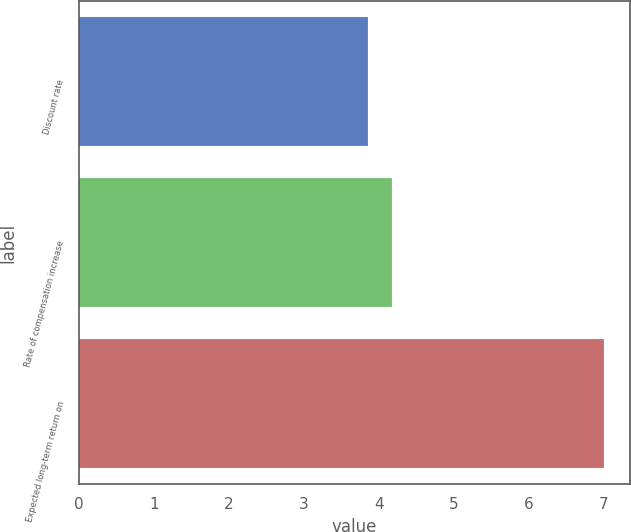<chart> <loc_0><loc_0><loc_500><loc_500><bar_chart><fcel>Discount rate<fcel>Rate of compensation increase<fcel>Expected long-term return on<nl><fcel>3.85<fcel>4.17<fcel>7<nl></chart> 